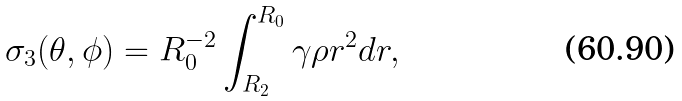<formula> <loc_0><loc_0><loc_500><loc_500>\sigma _ { 3 } ( \theta , \phi ) = R _ { 0 } ^ { - 2 } \int _ { R _ { 2 } } ^ { R _ { 0 } } \gamma \rho r ^ { 2 } d r ,</formula> 